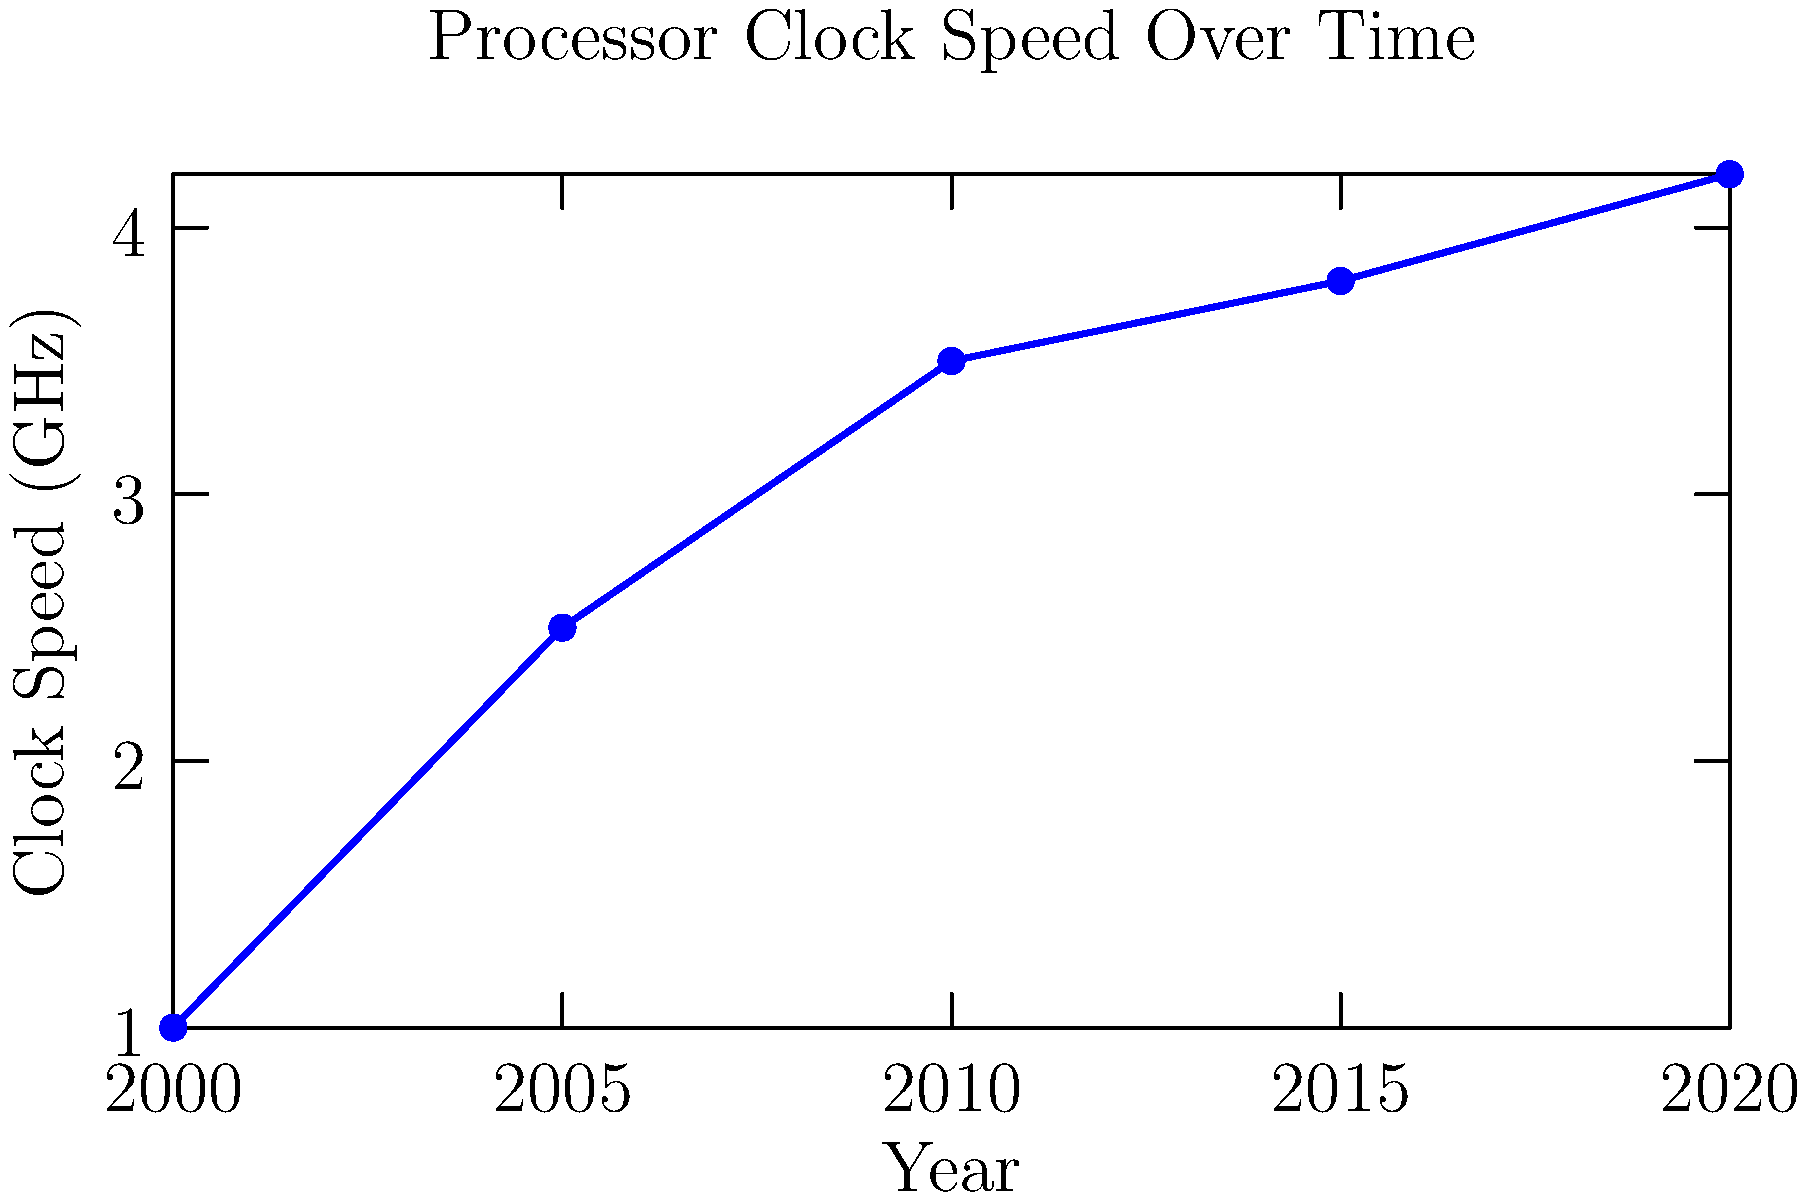Based on the line graph showing processor clock speeds from 2000 to 2020, what's the approximate percentage increase in clock speed between 2000 and 2020? To calculate the percentage increase in clock speed between 2000 and 2020:

1. Identify the clock speeds:
   - 2000: 1 GHz
   - 2020: 4.2 GHz

2. Calculate the difference:
   $4.2 \text{ GHz} - 1 \text{ GHz} = 3.2 \text{ GHz}$

3. Calculate the percentage increase:
   $$\text{Percentage increase} = \frac{\text{Increase}}{\text{Original Value}} \times 100\%$$
   $$= \frac{3.2 \text{ GHz}}{1 \text{ GHz}} \times 100\% = 320\%$$

Therefore, the approximate percentage increase in clock speed between 2000 and 2020 is 320%.
Answer: 320% 